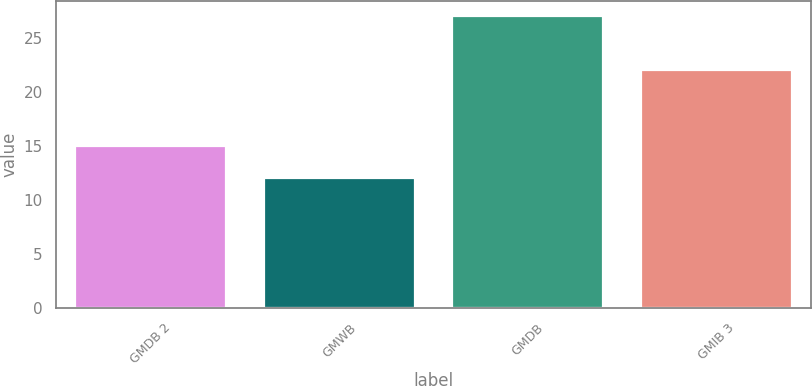Convert chart to OTSL. <chart><loc_0><loc_0><loc_500><loc_500><bar_chart><fcel>GMDB 2<fcel>GMWB<fcel>GMDB<fcel>GMIB 3<nl><fcel>15<fcel>12<fcel>27<fcel>22<nl></chart> 